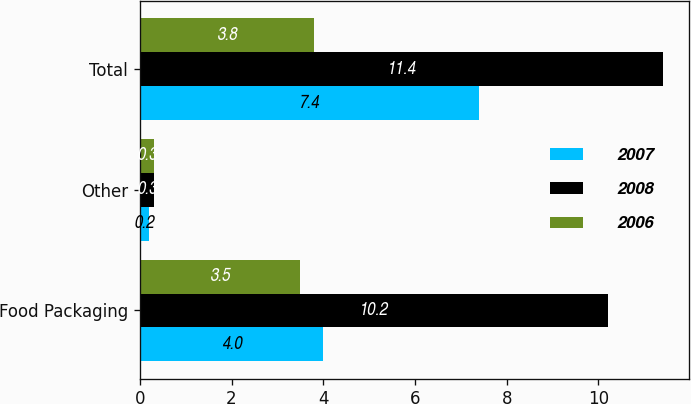Convert chart to OTSL. <chart><loc_0><loc_0><loc_500><loc_500><stacked_bar_chart><ecel><fcel>Food Packaging<fcel>Other<fcel>Total<nl><fcel>2007<fcel>4<fcel>0.2<fcel>7.4<nl><fcel>2008<fcel>10.2<fcel>0.3<fcel>11.4<nl><fcel>2006<fcel>3.5<fcel>0.3<fcel>3.8<nl></chart> 